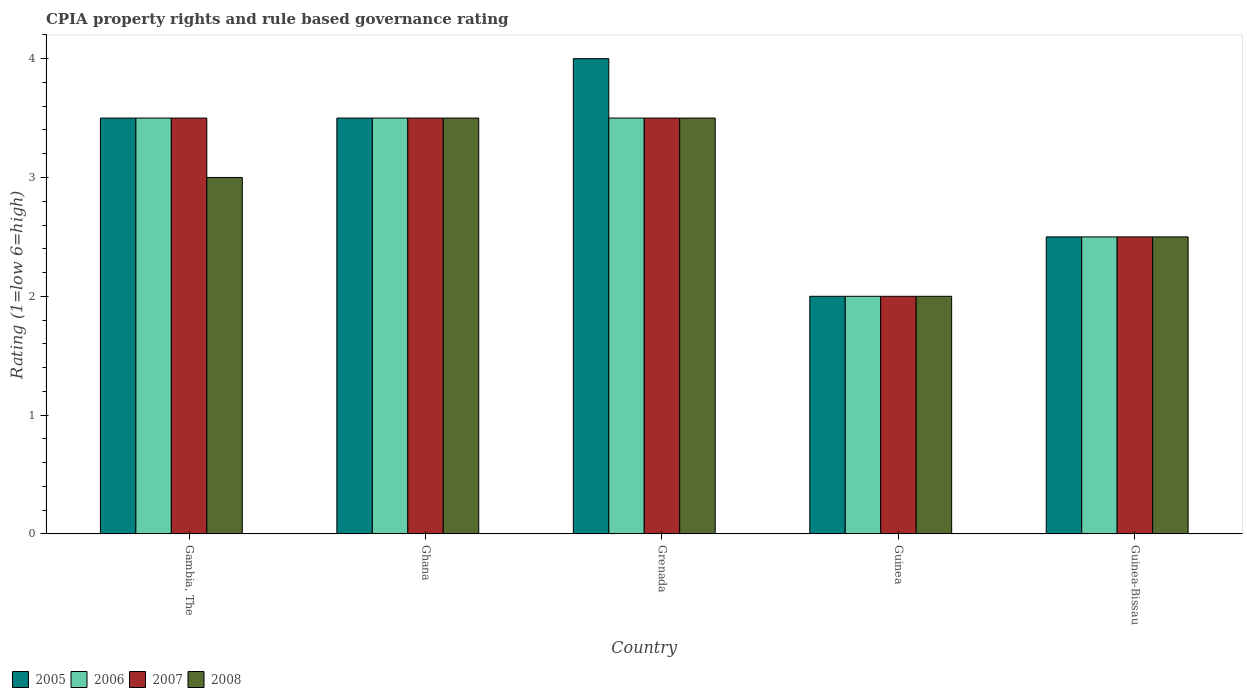How many groups of bars are there?
Provide a short and direct response. 5. Are the number of bars per tick equal to the number of legend labels?
Your answer should be compact. Yes. Are the number of bars on each tick of the X-axis equal?
Offer a very short reply. Yes. How many bars are there on the 1st tick from the left?
Your answer should be very brief. 4. What is the label of the 5th group of bars from the left?
Give a very brief answer. Guinea-Bissau. In how many cases, is the number of bars for a given country not equal to the number of legend labels?
Make the answer very short. 0. In which country was the CPIA rating in 2008 maximum?
Provide a succinct answer. Ghana. In which country was the CPIA rating in 2007 minimum?
Provide a succinct answer. Guinea. What is the difference between the CPIA rating in 2005 in Gambia, The and that in Guinea-Bissau?
Your answer should be very brief. 1. What is the difference between the CPIA rating in 2005 in Guinea and the CPIA rating in 2006 in Ghana?
Keep it short and to the point. -1.5. What is the average CPIA rating in 2008 per country?
Offer a terse response. 2.9. What is the ratio of the CPIA rating in 2006 in Gambia, The to that in Grenada?
Provide a succinct answer. 1. Is the CPIA rating in 2008 in Grenada less than that in Guinea?
Your answer should be compact. No. What is the difference between the highest and the second highest CPIA rating in 2008?
Your answer should be very brief. -0.5. In how many countries, is the CPIA rating in 2007 greater than the average CPIA rating in 2007 taken over all countries?
Provide a short and direct response. 3. Is it the case that in every country, the sum of the CPIA rating in 2006 and CPIA rating in 2005 is greater than the sum of CPIA rating in 2007 and CPIA rating in 2008?
Give a very brief answer. No. What does the 3rd bar from the left in Ghana represents?
Provide a short and direct response. 2007. What does the 3rd bar from the right in Ghana represents?
Provide a short and direct response. 2006. Is it the case that in every country, the sum of the CPIA rating in 2008 and CPIA rating in 2007 is greater than the CPIA rating in 2006?
Your response must be concise. Yes. How many countries are there in the graph?
Your answer should be compact. 5. What is the difference between two consecutive major ticks on the Y-axis?
Your answer should be compact. 1. Where does the legend appear in the graph?
Your answer should be compact. Bottom left. How many legend labels are there?
Ensure brevity in your answer.  4. How are the legend labels stacked?
Ensure brevity in your answer.  Horizontal. What is the title of the graph?
Your answer should be compact. CPIA property rights and rule based governance rating. Does "2012" appear as one of the legend labels in the graph?
Ensure brevity in your answer.  No. What is the label or title of the X-axis?
Offer a terse response. Country. What is the label or title of the Y-axis?
Offer a very short reply. Rating (1=low 6=high). What is the Rating (1=low 6=high) of 2005 in Gambia, The?
Your response must be concise. 3.5. What is the Rating (1=low 6=high) in 2007 in Gambia, The?
Your answer should be compact. 3.5. What is the Rating (1=low 6=high) of 2008 in Gambia, The?
Your answer should be compact. 3. What is the Rating (1=low 6=high) in 2005 in Ghana?
Keep it short and to the point. 3.5. What is the Rating (1=low 6=high) of 2006 in Ghana?
Ensure brevity in your answer.  3.5. What is the Rating (1=low 6=high) of 2007 in Grenada?
Your response must be concise. 3.5. What is the Rating (1=low 6=high) in 2005 in Guinea?
Your answer should be very brief. 2. What is the Rating (1=low 6=high) in 2007 in Guinea?
Make the answer very short. 2. What is the Rating (1=low 6=high) of 2007 in Guinea-Bissau?
Keep it short and to the point. 2.5. What is the Rating (1=low 6=high) in 2008 in Guinea-Bissau?
Give a very brief answer. 2.5. Across all countries, what is the minimum Rating (1=low 6=high) of 2006?
Give a very brief answer. 2. What is the total Rating (1=low 6=high) in 2006 in the graph?
Ensure brevity in your answer.  15. What is the total Rating (1=low 6=high) of 2008 in the graph?
Offer a very short reply. 14.5. What is the difference between the Rating (1=low 6=high) of 2005 in Gambia, The and that in Ghana?
Keep it short and to the point. 0. What is the difference between the Rating (1=low 6=high) of 2006 in Gambia, The and that in Ghana?
Give a very brief answer. 0. What is the difference between the Rating (1=low 6=high) of 2008 in Gambia, The and that in Ghana?
Give a very brief answer. -0.5. What is the difference between the Rating (1=low 6=high) in 2005 in Gambia, The and that in Grenada?
Your response must be concise. -0.5. What is the difference between the Rating (1=low 6=high) of 2006 in Gambia, The and that in Grenada?
Your response must be concise. 0. What is the difference between the Rating (1=low 6=high) in 2007 in Gambia, The and that in Grenada?
Give a very brief answer. 0. What is the difference between the Rating (1=low 6=high) in 2008 in Gambia, The and that in Grenada?
Keep it short and to the point. -0.5. What is the difference between the Rating (1=low 6=high) of 2005 in Gambia, The and that in Guinea?
Provide a succinct answer. 1.5. What is the difference between the Rating (1=low 6=high) in 2005 in Ghana and that in Grenada?
Offer a very short reply. -0.5. What is the difference between the Rating (1=low 6=high) of 2006 in Ghana and that in Grenada?
Your response must be concise. 0. What is the difference between the Rating (1=low 6=high) in 2008 in Ghana and that in Guinea?
Your response must be concise. 1.5. What is the difference between the Rating (1=low 6=high) of 2005 in Ghana and that in Guinea-Bissau?
Give a very brief answer. 1. What is the difference between the Rating (1=low 6=high) of 2006 in Ghana and that in Guinea-Bissau?
Your answer should be very brief. 1. What is the difference between the Rating (1=low 6=high) in 2007 in Ghana and that in Guinea-Bissau?
Provide a short and direct response. 1. What is the difference between the Rating (1=low 6=high) of 2008 in Ghana and that in Guinea-Bissau?
Provide a short and direct response. 1. What is the difference between the Rating (1=low 6=high) of 2005 in Grenada and that in Guinea?
Ensure brevity in your answer.  2. What is the difference between the Rating (1=low 6=high) of 2006 in Grenada and that in Guinea?
Offer a very short reply. 1.5. What is the difference between the Rating (1=low 6=high) of 2006 in Grenada and that in Guinea-Bissau?
Your answer should be compact. 1. What is the difference between the Rating (1=low 6=high) in 2007 in Grenada and that in Guinea-Bissau?
Keep it short and to the point. 1. What is the difference between the Rating (1=low 6=high) of 2006 in Guinea and that in Guinea-Bissau?
Offer a terse response. -0.5. What is the difference between the Rating (1=low 6=high) in 2007 in Guinea and that in Guinea-Bissau?
Keep it short and to the point. -0.5. What is the difference between the Rating (1=low 6=high) in 2008 in Guinea and that in Guinea-Bissau?
Make the answer very short. -0.5. What is the difference between the Rating (1=low 6=high) of 2005 in Gambia, The and the Rating (1=low 6=high) of 2006 in Ghana?
Provide a short and direct response. 0. What is the difference between the Rating (1=low 6=high) in 2006 in Gambia, The and the Rating (1=low 6=high) in 2008 in Ghana?
Keep it short and to the point. 0. What is the difference between the Rating (1=low 6=high) of 2005 in Gambia, The and the Rating (1=low 6=high) of 2006 in Grenada?
Your response must be concise. 0. What is the difference between the Rating (1=low 6=high) of 2005 in Gambia, The and the Rating (1=low 6=high) of 2008 in Grenada?
Provide a succinct answer. 0. What is the difference between the Rating (1=low 6=high) of 2007 in Gambia, The and the Rating (1=low 6=high) of 2008 in Grenada?
Offer a terse response. 0. What is the difference between the Rating (1=low 6=high) of 2005 in Gambia, The and the Rating (1=low 6=high) of 2006 in Guinea?
Keep it short and to the point. 1.5. What is the difference between the Rating (1=low 6=high) in 2006 in Gambia, The and the Rating (1=low 6=high) in 2008 in Guinea?
Offer a very short reply. 1.5. What is the difference between the Rating (1=low 6=high) in 2005 in Gambia, The and the Rating (1=low 6=high) in 2006 in Guinea-Bissau?
Give a very brief answer. 1. What is the difference between the Rating (1=low 6=high) in 2006 in Gambia, The and the Rating (1=low 6=high) in 2007 in Guinea-Bissau?
Offer a terse response. 1. What is the difference between the Rating (1=low 6=high) of 2006 in Gambia, The and the Rating (1=low 6=high) of 2008 in Guinea-Bissau?
Provide a short and direct response. 1. What is the difference between the Rating (1=low 6=high) of 2005 in Ghana and the Rating (1=low 6=high) of 2006 in Grenada?
Make the answer very short. 0. What is the difference between the Rating (1=low 6=high) in 2006 in Ghana and the Rating (1=low 6=high) in 2007 in Grenada?
Your answer should be very brief. 0. What is the difference between the Rating (1=low 6=high) of 2006 in Ghana and the Rating (1=low 6=high) of 2008 in Grenada?
Offer a very short reply. 0. What is the difference between the Rating (1=low 6=high) in 2007 in Ghana and the Rating (1=low 6=high) in 2008 in Grenada?
Offer a terse response. 0. What is the difference between the Rating (1=low 6=high) in 2005 in Ghana and the Rating (1=low 6=high) in 2006 in Guinea?
Make the answer very short. 1.5. What is the difference between the Rating (1=low 6=high) of 2006 in Ghana and the Rating (1=low 6=high) of 2008 in Guinea?
Offer a very short reply. 1.5. What is the difference between the Rating (1=low 6=high) of 2005 in Grenada and the Rating (1=low 6=high) of 2007 in Guinea?
Your response must be concise. 2. What is the difference between the Rating (1=low 6=high) in 2006 in Grenada and the Rating (1=low 6=high) in 2007 in Guinea?
Your response must be concise. 1.5. What is the difference between the Rating (1=low 6=high) in 2006 in Grenada and the Rating (1=low 6=high) in 2008 in Guinea?
Your response must be concise. 1.5. What is the difference between the Rating (1=low 6=high) in 2005 in Grenada and the Rating (1=low 6=high) in 2008 in Guinea-Bissau?
Give a very brief answer. 1.5. What is the difference between the Rating (1=low 6=high) of 2006 in Grenada and the Rating (1=low 6=high) of 2007 in Guinea-Bissau?
Make the answer very short. 1. What is the difference between the Rating (1=low 6=high) in 2006 in Grenada and the Rating (1=low 6=high) in 2008 in Guinea-Bissau?
Make the answer very short. 1. What is the difference between the Rating (1=low 6=high) in 2007 in Grenada and the Rating (1=low 6=high) in 2008 in Guinea-Bissau?
Keep it short and to the point. 1. What is the difference between the Rating (1=low 6=high) in 2005 in Guinea and the Rating (1=low 6=high) in 2007 in Guinea-Bissau?
Your response must be concise. -0.5. What is the difference between the Rating (1=low 6=high) in 2006 in Guinea and the Rating (1=low 6=high) in 2007 in Guinea-Bissau?
Provide a short and direct response. -0.5. What is the average Rating (1=low 6=high) in 2005 per country?
Your answer should be very brief. 3.1. What is the average Rating (1=low 6=high) in 2006 per country?
Your answer should be very brief. 3. What is the average Rating (1=low 6=high) in 2008 per country?
Offer a terse response. 2.9. What is the difference between the Rating (1=low 6=high) of 2005 and Rating (1=low 6=high) of 2006 in Gambia, The?
Provide a short and direct response. 0. What is the difference between the Rating (1=low 6=high) of 2006 and Rating (1=low 6=high) of 2007 in Gambia, The?
Make the answer very short. 0. What is the difference between the Rating (1=low 6=high) of 2006 and Rating (1=low 6=high) of 2008 in Gambia, The?
Offer a very short reply. 0.5. What is the difference between the Rating (1=low 6=high) of 2007 and Rating (1=low 6=high) of 2008 in Gambia, The?
Your answer should be compact. 0.5. What is the difference between the Rating (1=low 6=high) of 2005 and Rating (1=low 6=high) of 2006 in Ghana?
Make the answer very short. 0. What is the difference between the Rating (1=low 6=high) of 2006 and Rating (1=low 6=high) of 2007 in Ghana?
Offer a very short reply. 0. What is the difference between the Rating (1=low 6=high) in 2007 and Rating (1=low 6=high) in 2008 in Ghana?
Offer a terse response. 0. What is the difference between the Rating (1=low 6=high) of 2005 and Rating (1=low 6=high) of 2006 in Grenada?
Offer a terse response. 0.5. What is the difference between the Rating (1=low 6=high) of 2005 and Rating (1=low 6=high) of 2007 in Grenada?
Offer a very short reply. 0.5. What is the difference between the Rating (1=low 6=high) of 2005 and Rating (1=low 6=high) of 2008 in Grenada?
Your answer should be very brief. 0.5. What is the difference between the Rating (1=low 6=high) in 2006 and Rating (1=low 6=high) in 2008 in Grenada?
Make the answer very short. 0. What is the difference between the Rating (1=low 6=high) of 2007 and Rating (1=low 6=high) of 2008 in Grenada?
Give a very brief answer. 0. What is the difference between the Rating (1=low 6=high) of 2005 and Rating (1=low 6=high) of 2006 in Guinea?
Ensure brevity in your answer.  0. What is the difference between the Rating (1=low 6=high) in 2005 and Rating (1=low 6=high) in 2008 in Guinea?
Ensure brevity in your answer.  0. What is the difference between the Rating (1=low 6=high) in 2006 and Rating (1=low 6=high) in 2008 in Guinea?
Provide a short and direct response. 0. What is the difference between the Rating (1=low 6=high) in 2007 and Rating (1=low 6=high) in 2008 in Guinea?
Make the answer very short. 0. What is the difference between the Rating (1=low 6=high) in 2006 and Rating (1=low 6=high) in 2008 in Guinea-Bissau?
Provide a succinct answer. 0. What is the difference between the Rating (1=low 6=high) of 2007 and Rating (1=low 6=high) of 2008 in Guinea-Bissau?
Ensure brevity in your answer.  0. What is the ratio of the Rating (1=low 6=high) of 2005 in Gambia, The to that in Ghana?
Your answer should be very brief. 1. What is the ratio of the Rating (1=low 6=high) of 2006 in Gambia, The to that in Ghana?
Your answer should be compact. 1. What is the ratio of the Rating (1=low 6=high) in 2008 in Gambia, The to that in Ghana?
Give a very brief answer. 0.86. What is the ratio of the Rating (1=low 6=high) of 2005 in Gambia, The to that in Grenada?
Give a very brief answer. 0.88. What is the ratio of the Rating (1=low 6=high) of 2006 in Gambia, The to that in Grenada?
Provide a succinct answer. 1. What is the ratio of the Rating (1=low 6=high) in 2008 in Gambia, The to that in Grenada?
Your answer should be very brief. 0.86. What is the ratio of the Rating (1=low 6=high) of 2008 in Gambia, The to that in Guinea?
Provide a succinct answer. 1.5. What is the ratio of the Rating (1=low 6=high) in 2005 in Gambia, The to that in Guinea-Bissau?
Your answer should be compact. 1.4. What is the ratio of the Rating (1=low 6=high) in 2006 in Gambia, The to that in Guinea-Bissau?
Offer a very short reply. 1.4. What is the ratio of the Rating (1=low 6=high) in 2007 in Gambia, The to that in Guinea-Bissau?
Give a very brief answer. 1.4. What is the ratio of the Rating (1=low 6=high) of 2005 in Ghana to that in Grenada?
Your answer should be very brief. 0.88. What is the ratio of the Rating (1=low 6=high) of 2006 in Ghana to that in Guinea?
Ensure brevity in your answer.  1.75. What is the ratio of the Rating (1=low 6=high) in 2008 in Ghana to that in Guinea?
Your answer should be compact. 1.75. What is the ratio of the Rating (1=low 6=high) of 2005 in Ghana to that in Guinea-Bissau?
Offer a very short reply. 1.4. What is the ratio of the Rating (1=low 6=high) in 2007 in Ghana to that in Guinea-Bissau?
Offer a very short reply. 1.4. What is the ratio of the Rating (1=low 6=high) in 2006 in Grenada to that in Guinea?
Your answer should be compact. 1.75. What is the ratio of the Rating (1=low 6=high) of 2007 in Grenada to that in Guinea?
Make the answer very short. 1.75. What is the ratio of the Rating (1=low 6=high) of 2008 in Grenada to that in Guinea?
Ensure brevity in your answer.  1.75. What is the ratio of the Rating (1=low 6=high) of 2007 in Grenada to that in Guinea-Bissau?
Provide a short and direct response. 1.4. What is the ratio of the Rating (1=low 6=high) of 2006 in Guinea to that in Guinea-Bissau?
Offer a very short reply. 0.8. What is the ratio of the Rating (1=low 6=high) of 2007 in Guinea to that in Guinea-Bissau?
Offer a very short reply. 0.8. What is the difference between the highest and the second highest Rating (1=low 6=high) in 2005?
Provide a succinct answer. 0.5. What is the difference between the highest and the second highest Rating (1=low 6=high) in 2006?
Offer a terse response. 0. What is the difference between the highest and the lowest Rating (1=low 6=high) in 2005?
Keep it short and to the point. 2. What is the difference between the highest and the lowest Rating (1=low 6=high) of 2008?
Your answer should be very brief. 1.5. 